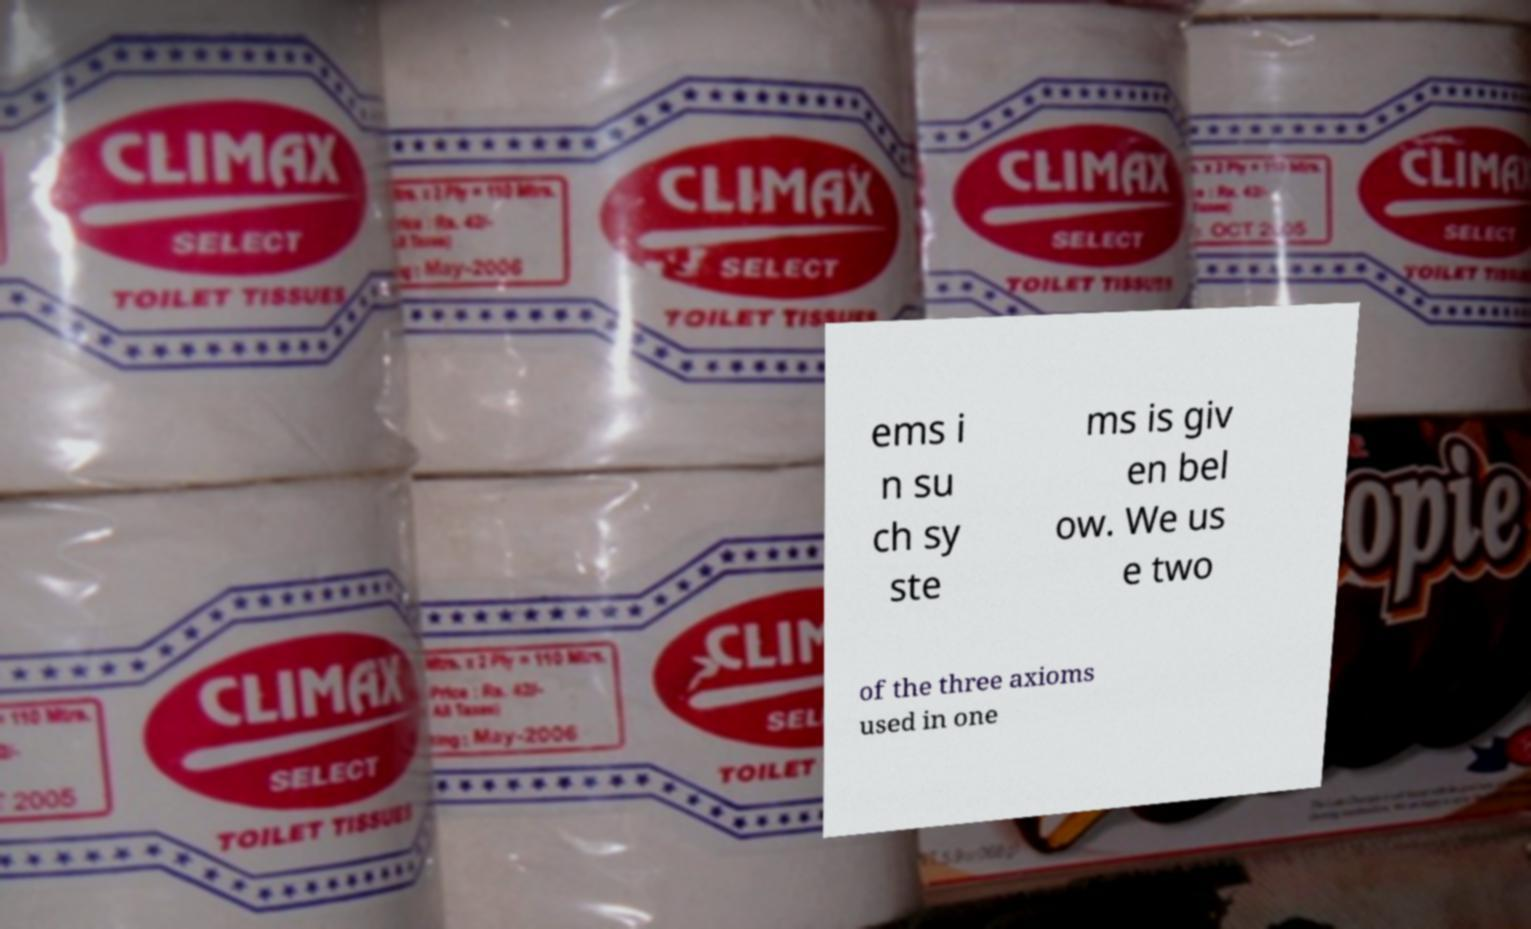What messages or text are displayed in this image? I need them in a readable, typed format. ems i n su ch sy ste ms is giv en bel ow. We us e two of the three axioms used in one 